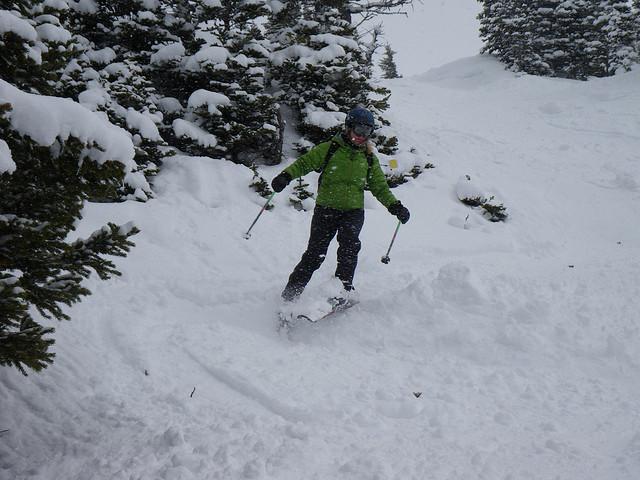What is he doing?
Be succinct. Skiing. What is on the ground?
Quick response, please. Snow. Is the man wearing head protection?
Keep it brief. Yes. Does the boy has ski poles?
Be succinct. Yes. What color is the jacket?
Keep it brief. Green. What is the closest person doing?
Give a very brief answer. Skiing. What color is the man wearing?
Concise answer only. Green. Is he skiing?
Quick response, please. Yes. 